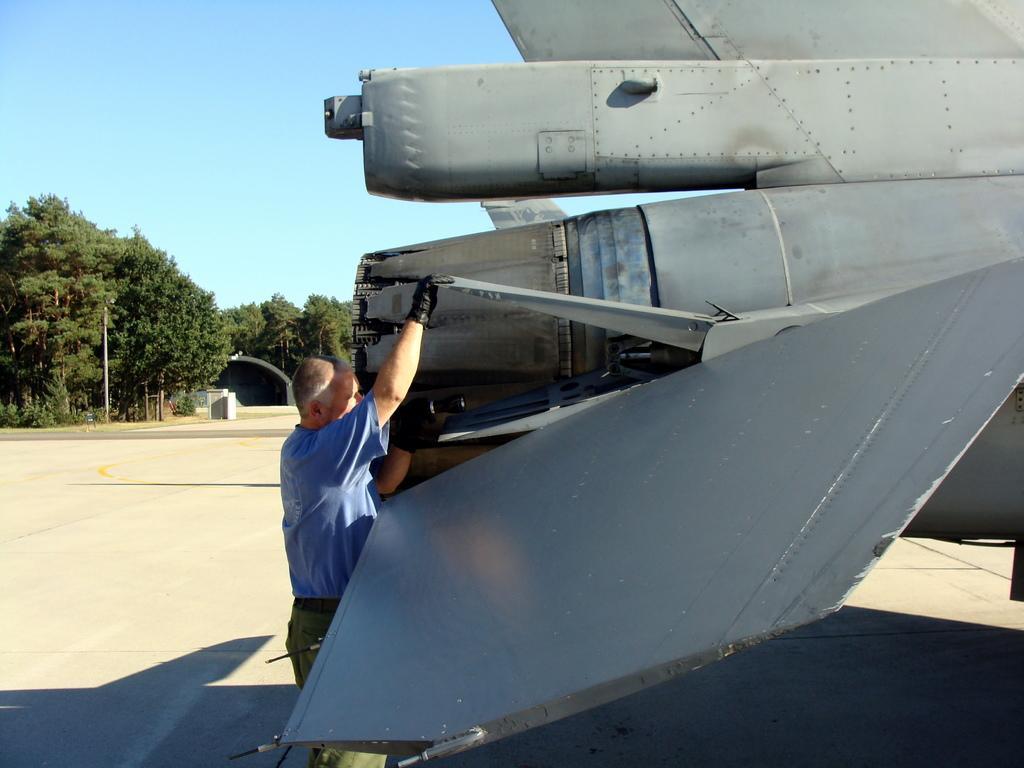How would you summarize this image in a sentence or two? This image is clicked outside. To the right, there is a plane. To the left, the man wearing blue shirt is repairing the plane. In the background, there are trees along with sky. At the bottom, there is road. 